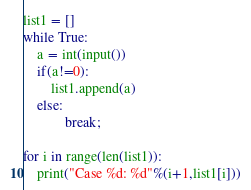Convert code to text. <code><loc_0><loc_0><loc_500><loc_500><_Python_>list1 = []
while True:
    a = int(input())
    if(a!=0):
        list1.append(a)
    else:
            break;

for i in range(len(list1)):
    print("Case %d: %d"%(i+1,list1[i]))
</code> 